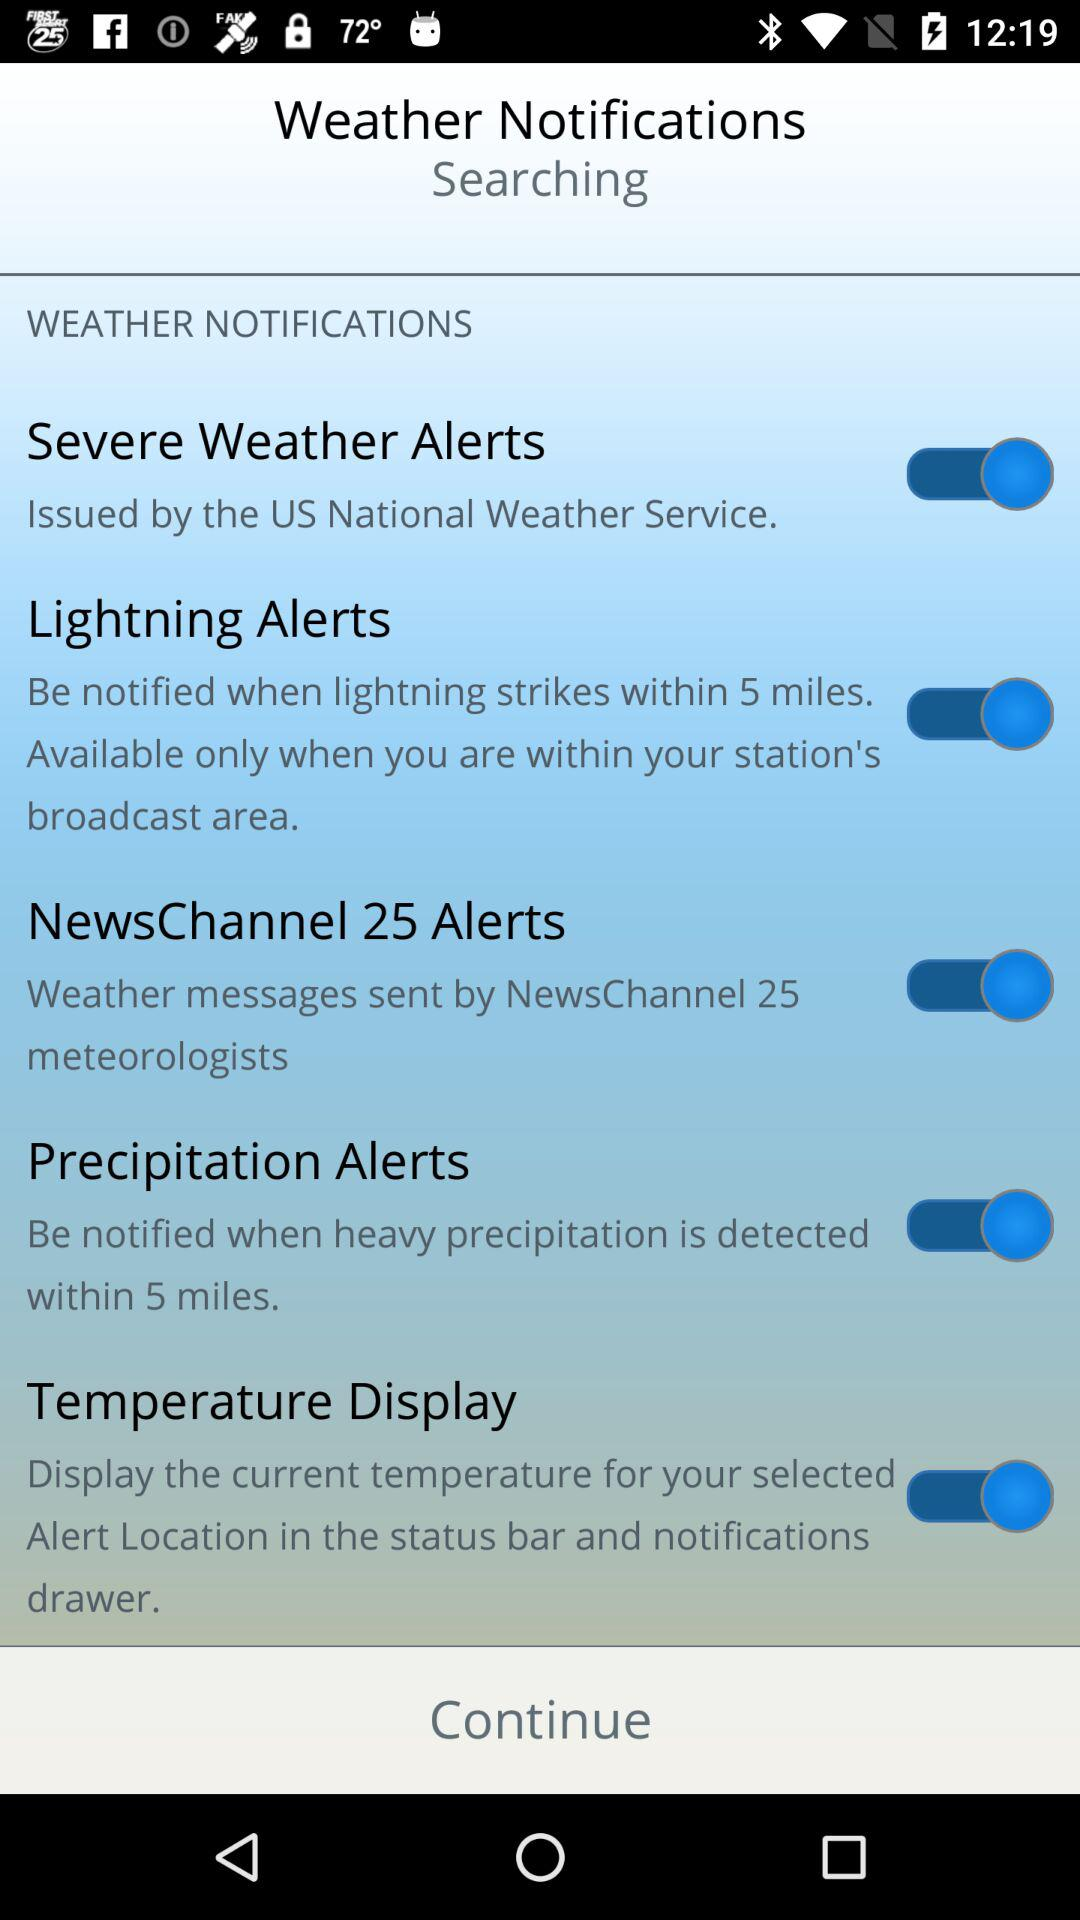What is the status of the "Lightning Alerts"? The "Lightning Alerts" status is on. 